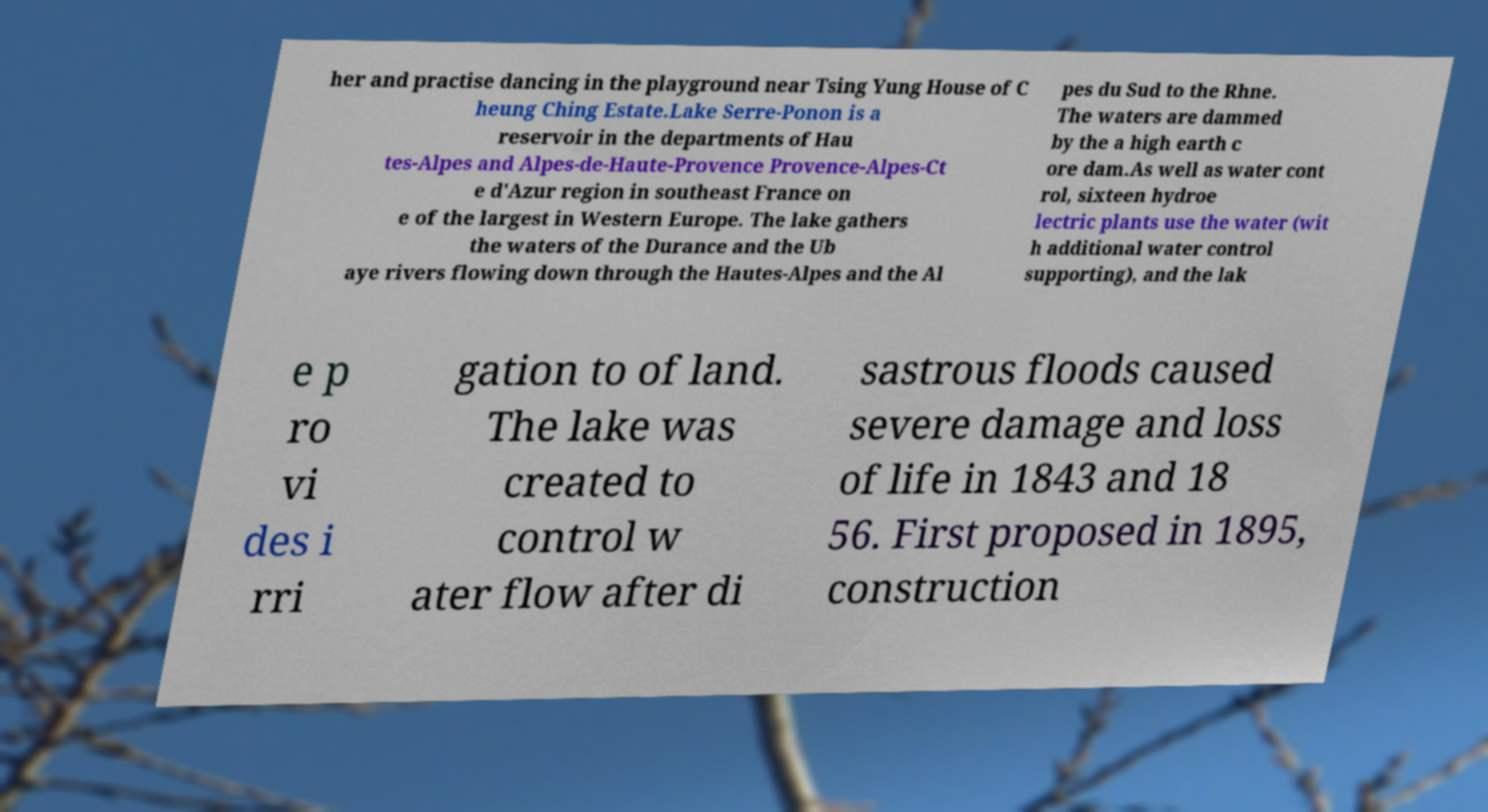There's text embedded in this image that I need extracted. Can you transcribe it verbatim? her and practise dancing in the playground near Tsing Yung House of C heung Ching Estate.Lake Serre-Ponon is a reservoir in the departments of Hau tes-Alpes and Alpes-de-Haute-Provence Provence-Alpes-Ct e d'Azur region in southeast France on e of the largest in Western Europe. The lake gathers the waters of the Durance and the Ub aye rivers flowing down through the Hautes-Alpes and the Al pes du Sud to the Rhne. The waters are dammed by the a high earth c ore dam.As well as water cont rol, sixteen hydroe lectric plants use the water (wit h additional water control supporting), and the lak e p ro vi des i rri gation to of land. The lake was created to control w ater flow after di sastrous floods caused severe damage and loss of life in 1843 and 18 56. First proposed in 1895, construction 